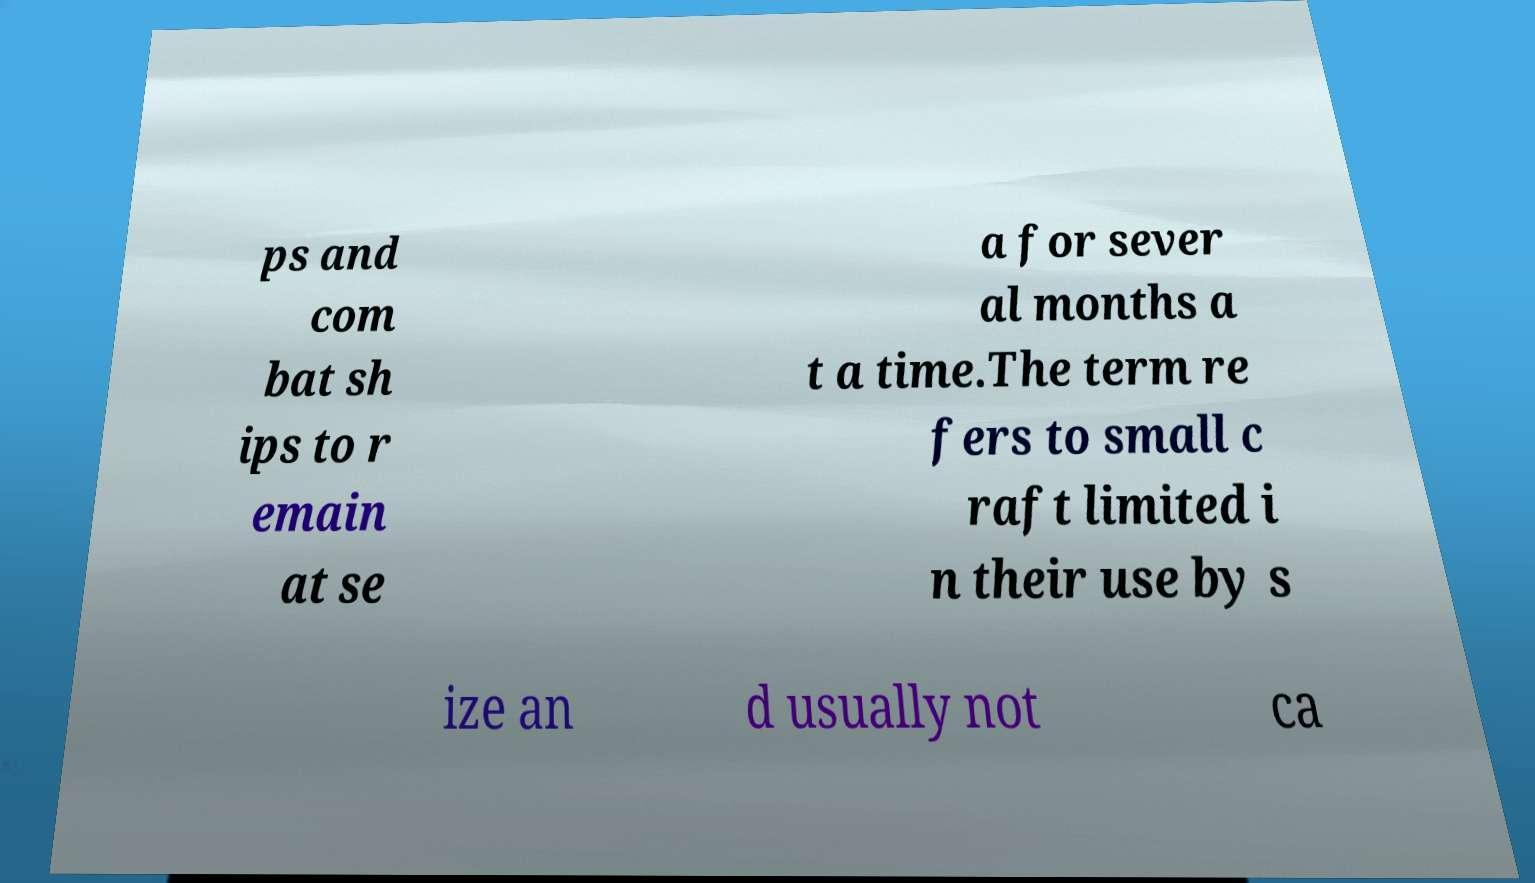For documentation purposes, I need the text within this image transcribed. Could you provide that? ps and com bat sh ips to r emain at se a for sever al months a t a time.The term re fers to small c raft limited i n their use by s ize an d usually not ca 